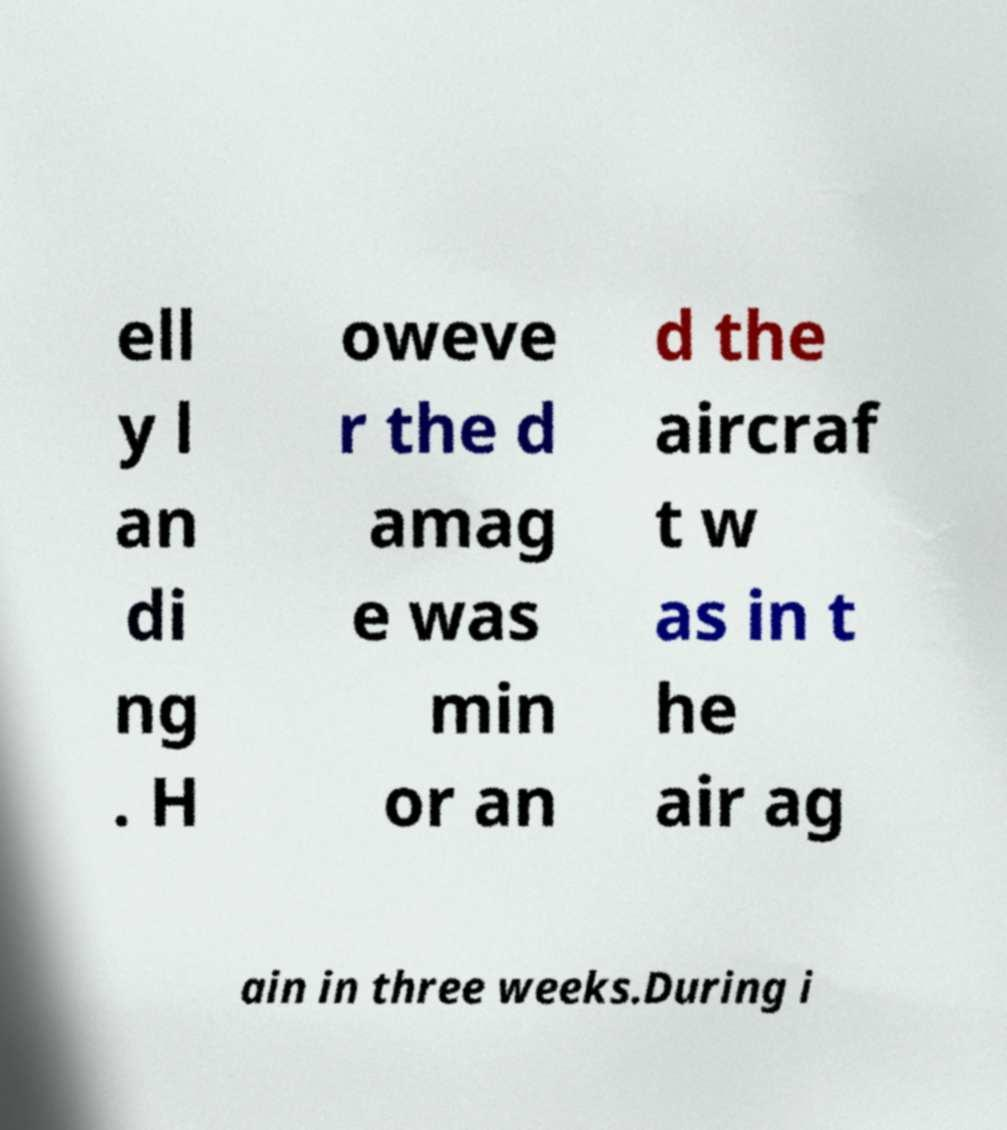I need the written content from this picture converted into text. Can you do that? ell y l an di ng . H oweve r the d amag e was min or an d the aircraf t w as in t he air ag ain in three weeks.During i 